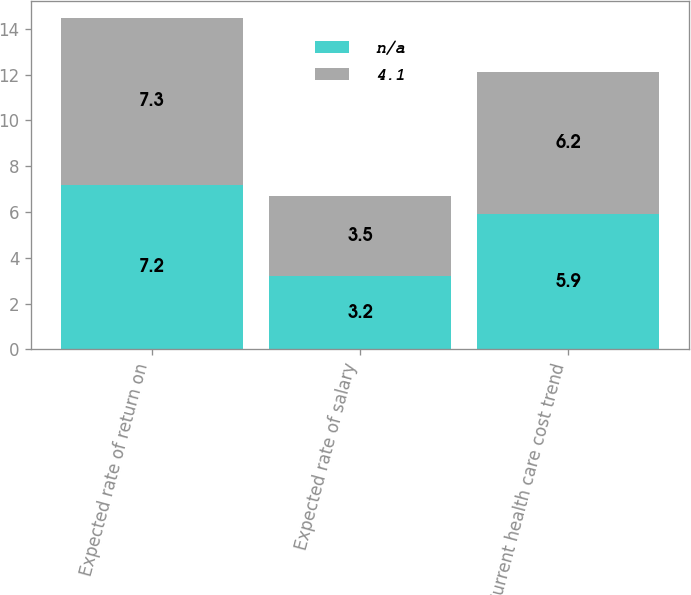<chart> <loc_0><loc_0><loc_500><loc_500><stacked_bar_chart><ecel><fcel>Expected rate of return on<fcel>Expected rate of salary<fcel>Current health care cost trend<nl><fcel>nan<fcel>7.2<fcel>3.2<fcel>5.9<nl><fcel>4.1<fcel>7.3<fcel>3.5<fcel>6.2<nl></chart> 